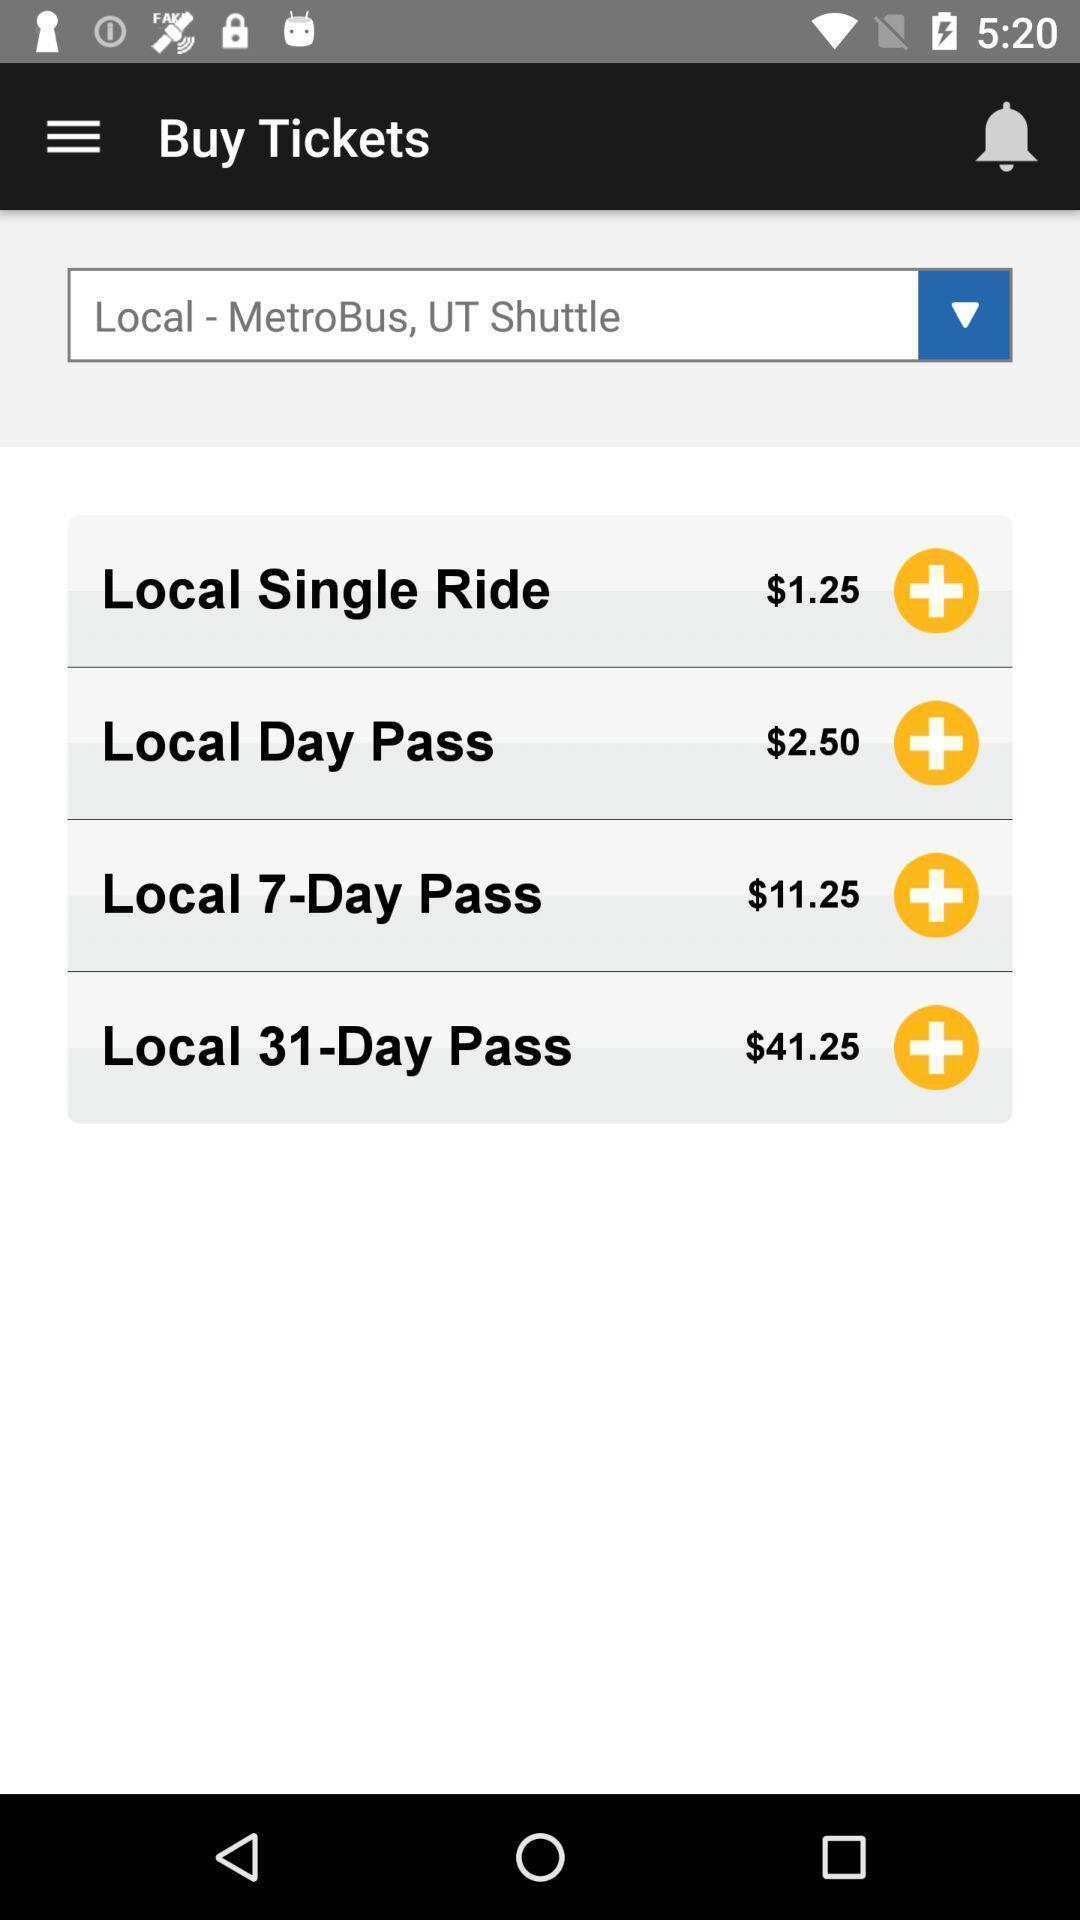Provide a description of this screenshot. Page displaying the different fares of passes. 